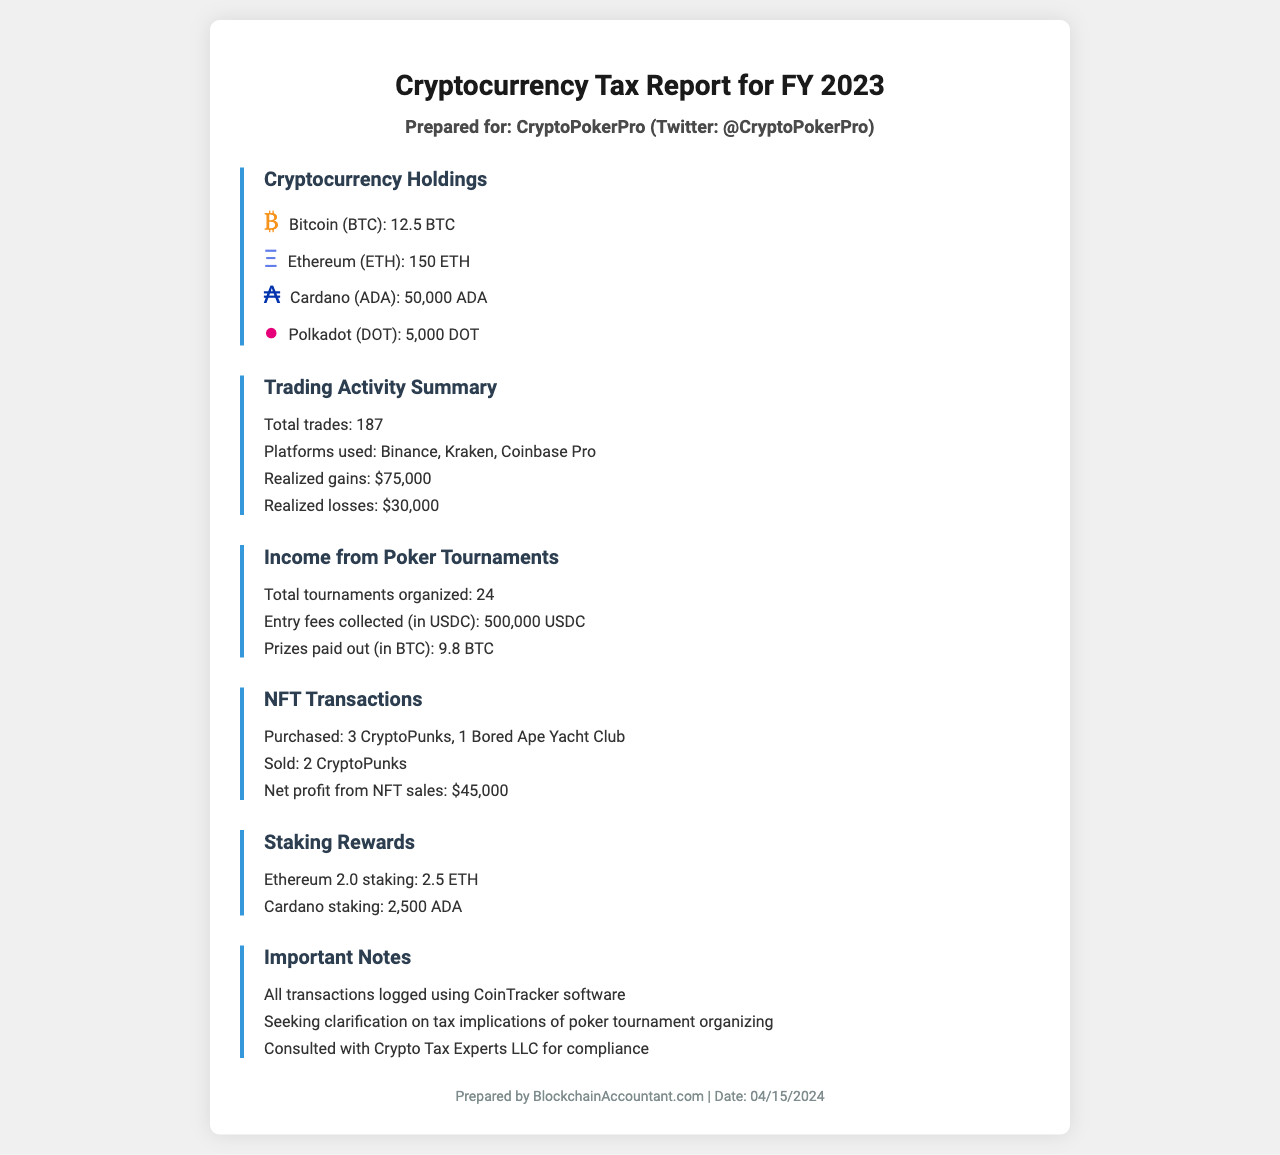what is the total amount of Bitcoin held? The total amount of Bitcoin held is explicitly listed in the document under cryptocurrency holdings.
Answer: 12.5 BTC how many Ethereum are included in the holdings? The document specifies the amount of Ethereum held under cryptocurrency holdings.
Answer: 150 ETH what is the realized gain from trading activities? The realized gains from trading activities is provided in the trading activity summary section of the document.
Answer: $75,000 how many poker tournaments were organized in FY 2023? The total number of tournaments organized is stated in the income from poker tournaments section.
Answer: 24 what is the net profit from NFT sales? The net profit from NFT sales is mentioned in the NFT transactions section of the document.
Answer: $45,000 which platforms were used for trading? The trading activity summary indicates the platforms where trades occurred.
Answer: Binance, Kraken, Coinbase Pro what staking rewards were earned from Ethereum 2.0? The document specifies the amount of staking rewards earned from Ethereum 2.0.
Answer: 2.5 ETH what is stated under important notes regarding tax compliance? The document highlights specific notes regarding compliance with tax regulations.
Answer: Consulted with Crypto Tax Experts LLC for compliance 